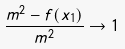Convert formula to latex. <formula><loc_0><loc_0><loc_500><loc_500>\frac { m ^ { 2 } - f ( x _ { 1 } ) } { m ^ { 2 } } \to 1</formula> 